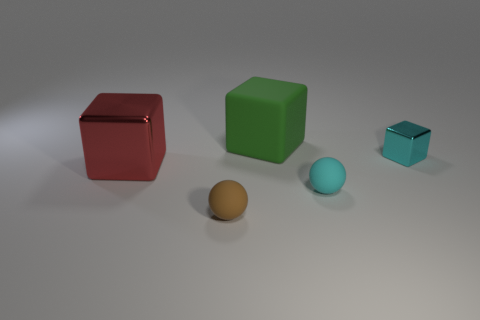There is a rubber ball that is behind the brown ball; is it the same color as the tiny cube?
Provide a succinct answer. Yes. Is there anything else that has the same color as the small metal thing?
Give a very brief answer. Yes. What size is the block that is both on the left side of the small shiny thing and on the right side of the big red metallic cube?
Provide a short and direct response. Large. How many red things are the same material as the green block?
Your answer should be compact. 0. What shape is the small rubber thing that is the same color as the small metallic thing?
Your answer should be very brief. Sphere. What color is the large metal block?
Ensure brevity in your answer.  Red. There is a cyan thing behind the big red thing; is it the same shape as the big red object?
Your answer should be very brief. Yes. How many things are objects right of the matte cube or cyan rubber blocks?
Make the answer very short. 2. Are there any other objects of the same shape as the tiny metal thing?
Your response must be concise. Yes. What is the shape of the rubber thing that is the same size as the brown ball?
Offer a very short reply. Sphere. 